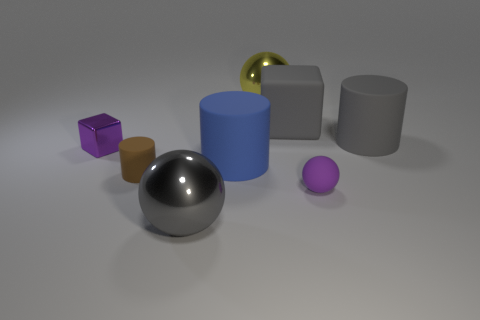Are there the same number of tiny purple rubber objects left of the large blue matte cylinder and brown matte cylinders that are behind the big gray cylinder?
Your answer should be very brief. Yes. Is the color of the large ball that is behind the big gray cylinder the same as the small matte thing in front of the brown rubber cylinder?
Offer a very short reply. No. Is the number of rubber things that are in front of the tiny brown rubber thing greater than the number of blue shiny cylinders?
Your answer should be compact. Yes. There is a brown object that is the same material as the tiny ball; what is its shape?
Offer a terse response. Cylinder. Do the metal ball that is behind the purple ball and the big gray block have the same size?
Offer a very short reply. Yes. There is a rubber thing to the left of the big metal object in front of the brown cylinder; what shape is it?
Your response must be concise. Cylinder. What size is the ball that is to the right of the big yellow ball that is behind the brown object?
Provide a succinct answer. Small. What color is the shiny sphere behind the purple shiny cube?
Offer a terse response. Yellow. What size is the gray cylinder that is the same material as the purple ball?
Offer a very short reply. Large. How many big gray metallic things have the same shape as the yellow shiny object?
Give a very brief answer. 1. 